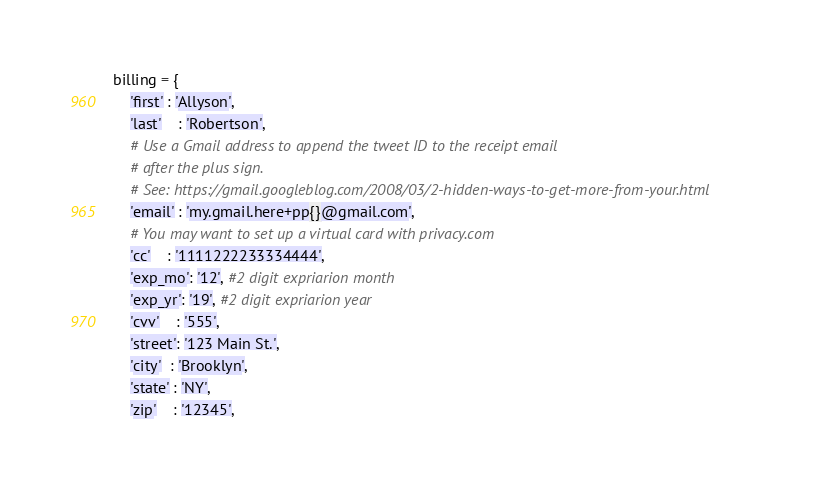Convert code to text. <code><loc_0><loc_0><loc_500><loc_500><_Python_>billing = {
	'first' : 'Allyson',
	'last'	: 'Robertson',
	# Use a Gmail address to append the tweet ID to the receipt email
	# after the plus sign.
	# See: https://gmail.googleblog.com/2008/03/2-hidden-ways-to-get-more-from-your.html
	'email' : 'my.gmail.here+pp{}@gmail.com',
	# You may want to set up a virtual card with privacy.com
	'cc'	: '1111222233334444',
	'exp_mo': '12', #2 digit expriarion month
 	'exp_yr': '19', #2 digit expriarion year
 	'cvv'	: '555',
 	'street': '123 Main St.',
 	'city'  : 'Brooklyn',
 	'state' : 'NY',
 	'zip'	: '12345',</code> 